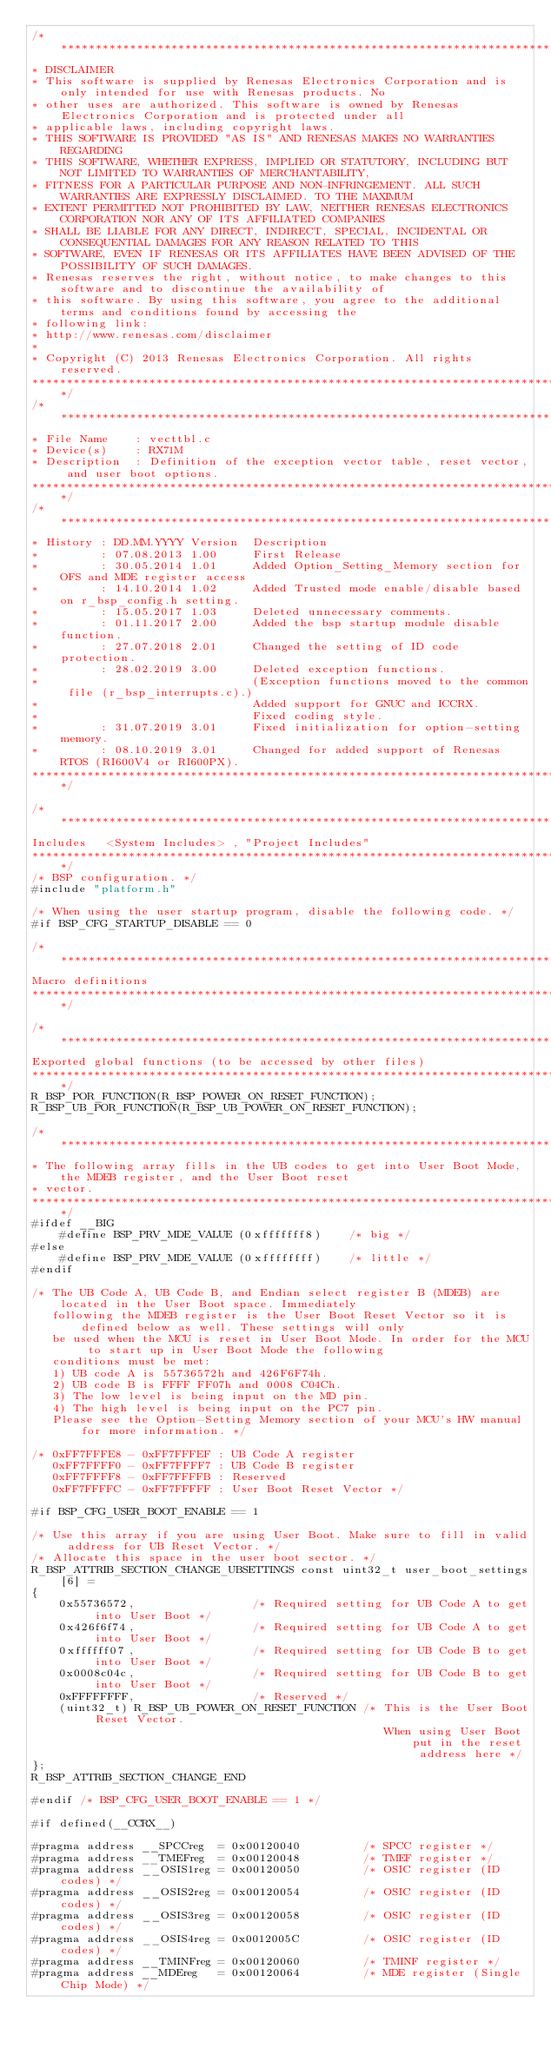Convert code to text. <code><loc_0><loc_0><loc_500><loc_500><_C_>/***********************************************************************************************************************
* DISCLAIMER
* This software is supplied by Renesas Electronics Corporation and is only intended for use with Renesas products. No 
* other uses are authorized. This software is owned by Renesas Electronics Corporation and is protected under all 
* applicable laws, including copyright laws. 
* THIS SOFTWARE IS PROVIDED "AS IS" AND RENESAS MAKES NO WARRANTIES REGARDING
* THIS SOFTWARE, WHETHER EXPRESS, IMPLIED OR STATUTORY, INCLUDING BUT NOT LIMITED TO WARRANTIES OF MERCHANTABILITY, 
* FITNESS FOR A PARTICULAR PURPOSE AND NON-INFRINGEMENT. ALL SUCH WARRANTIES ARE EXPRESSLY DISCLAIMED. TO THE MAXIMUM 
* EXTENT PERMITTED NOT PROHIBITED BY LAW, NEITHER RENESAS ELECTRONICS CORPORATION NOR ANY OF ITS AFFILIATED COMPANIES 
* SHALL BE LIABLE FOR ANY DIRECT, INDIRECT, SPECIAL, INCIDENTAL OR CONSEQUENTIAL DAMAGES FOR ANY REASON RELATED TO THIS 
* SOFTWARE, EVEN IF RENESAS OR ITS AFFILIATES HAVE BEEN ADVISED OF THE POSSIBILITY OF SUCH DAMAGES.
* Renesas reserves the right, without notice, to make changes to this software and to discontinue the availability of 
* this software. By using this software, you agree to the additional terms and conditions found by accessing the 
* following link:
* http://www.renesas.com/disclaimer
*
* Copyright (C) 2013 Renesas Electronics Corporation. All rights reserved.
***********************************************************************************************************************/
/***********************************************************************************************************************
* File Name    : vecttbl.c
* Device(s)    : RX71M
* Description  : Definition of the exception vector table, reset vector, and user boot options.
***********************************************************************************************************************/
/***********************************************************************************************************************
* History : DD.MM.YYYY Version  Description
*         : 07.08.2013 1.00     First Release
*         : 30.05.2014 1.01     Added Option_Setting_Memory section for OFS and MDE register access
*         : 14.10.2014 1.02     Added Trusted mode enable/disable based on r_bsp_config.h setting.
*         : 15.05.2017 1.03     Deleted unnecessary comments.
*         : 01.11.2017 2.00     Added the bsp startup module disable function.
*         : 27.07.2018 2.01     Changed the setting of ID code protection.
*         : 28.02.2019 3.00     Deleted exception functions.
*                               (Exception functions moved to the common file (r_bsp_interrupts.c).)
*                               Added support for GNUC and ICCRX.
*                               Fixed coding style.
*         : 31.07.2019 3.01     Fixed initialization for option-setting memory.
*         : 08.10.2019 3.01     Changed for added support of Renesas RTOS (RI600V4 or RI600PX).
***********************************************************************************************************************/

/***********************************************************************************************************************
Includes   <System Includes> , "Project Includes"
***********************************************************************************************************************/
/* BSP configuration. */
#include "platform.h"

/* When using the user startup program, disable the following code. */
#if BSP_CFG_STARTUP_DISABLE == 0

/***********************************************************************************************************************
Macro definitions
***********************************************************************************************************************/

/***********************************************************************************************************************
Exported global functions (to be accessed by other files)
***********************************************************************************************************************/
R_BSP_POR_FUNCTION(R_BSP_POWER_ON_RESET_FUNCTION);
R_BSP_UB_POR_FUNCTION(R_BSP_UB_POWER_ON_RESET_FUNCTION);

/***********************************************************************************************************************
* The following array fills in the UB codes to get into User Boot Mode, the MDEB register, and the User Boot reset
* vector.
***********************************************************************************************************************/
#ifdef __BIG
    #define BSP_PRV_MDE_VALUE (0xfffffff8)    /* big */
#else
    #define BSP_PRV_MDE_VALUE (0xffffffff)    /* little */
#endif

/* The UB Code A, UB Code B, and Endian select register B (MDEB) are located in the User Boot space. Immediately
   following the MDEB register is the User Boot Reset Vector so it is defined below as well. These settings will only
   be used when the MCU is reset in User Boot Mode. In order for the MCU to start up in User Boot Mode the following
   conditions must be met:
   1) UB code A is 55736572h and 426F6F74h.
   2) UB code B is FFFF FF07h and 0008 C04Ch.
   3) The low level is being input on the MD pin.
   4) The high level is being input on the PC7 pin.
   Please see the Option-Setting Memory section of your MCU's HW manual for more information. */

/* 0xFF7FFFE8 - 0xFF7FFFEF : UB Code A register
   0xFF7FFFF0 - 0xFF7FFFF7 : UB Code B register
   0xFF7FFFF8 - 0xFF7FFFFB : Reserved
   0xFF7FFFFC - 0xFF7FFFFF : User Boot Reset Vector */

#if BSP_CFG_USER_BOOT_ENABLE == 1

/* Use this array if you are using User Boot. Make sure to fill in valid address for UB Reset Vector. */
/* Allocate this space in the user boot sector. */
R_BSP_ATTRIB_SECTION_CHANGE_UBSETTINGS const uint32_t user_boot_settings[6] =
{
    0x55736572,                 /* Required setting for UB Code A to get into User Boot */
    0x426f6f74,                 /* Required setting for UB Code A to get into User Boot */
    0xffffff07,                 /* Required setting for UB Code B to get into User Boot */
    0x0008c04c,                 /* Required setting for UB Code B to get into User Boot */
    0xFFFFFFFF,                 /* Reserved */
    (uint32_t) R_BSP_UB_POWER_ON_RESET_FUNCTION /* This is the User Boot Reset Vector.
                                                   When using User Boot put in the reset address here */
};
R_BSP_ATTRIB_SECTION_CHANGE_END

#endif /* BSP_CFG_USER_BOOT_ENABLE == 1 */

#if defined(__CCRX__)

#pragma address __SPCCreg  = 0x00120040         /* SPCC register */
#pragma address __TMEFreg  = 0x00120048         /* TMEF register */
#pragma address __OSIS1reg = 0x00120050         /* OSIC register (ID codes) */
#pragma address __OSIS2reg = 0x00120054         /* OSIC register (ID codes) */
#pragma address __OSIS3reg = 0x00120058         /* OSIC register (ID codes) */
#pragma address __OSIS4reg = 0x0012005C         /* OSIC register (ID codes) */
#pragma address __TMINFreg = 0x00120060         /* TMINF register */
#pragma address __MDEreg   = 0x00120064         /* MDE register (Single Chip Mode) */</code> 